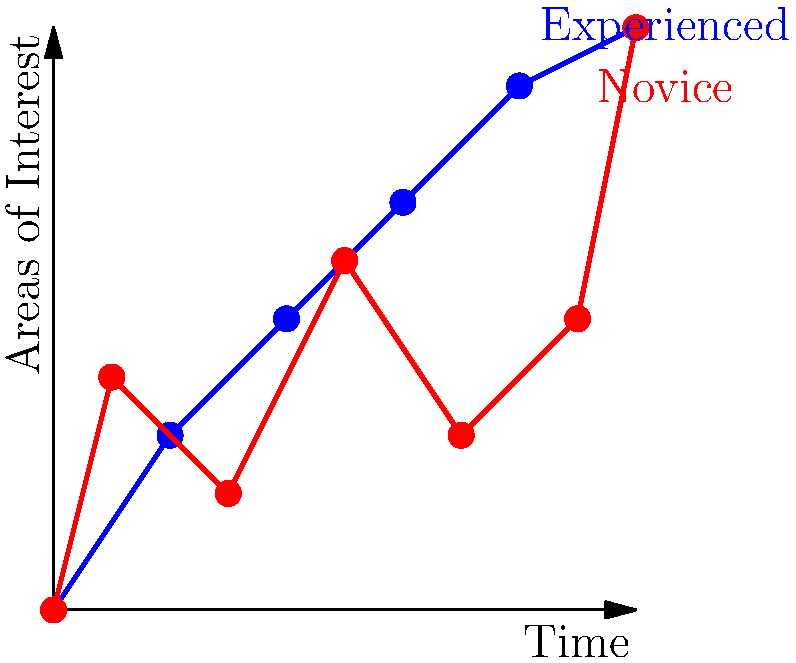Based on the gaze plot diagrams shown, which of the following statements best describes the difference in eye movement patterns between experienced and novice poker players?

A) Experienced players have more focused and direct gaze patterns
B) Novice players exhibit more consistent eye movements
C) Experienced players scan fewer areas of interest
D) Novice players have smoother transitions between areas of interest To answer this question, we need to analyze the gaze plot diagrams for both experienced and novice poker players:

1. Experienced players (blue line):
   - The line is relatively smooth and shows a more direct path from the starting point to the endpoint.
   - There are fewer fluctuations in the line, indicating more focused attention on specific areas of interest.
   - The pattern suggests efficient scanning of relevant information.

2. Novice players (red line):
   - The line shows more fluctuations and abrupt changes in direction.
   - There are more data points, indicating more frequent shifts in attention.
   - The pattern suggests less efficient scanning, with attention jumping between different areas of interest.

3. Comparing the two patterns:
   - Experienced players seem to have a more systematic and focused approach to visual information processing.
   - Novice players appear to have a more erratic and less organized visual search strategy.

4. Analyzing the options:
   A) This statement accurately describes the observed difference. Experienced players show a more direct and focused gaze pattern.
   B) This is incorrect, as novice players actually show less consistent eye movements.
   C) This is not supported by the diagram, as we can't determine the number of areas scanned.
   D) This is incorrect, as novice players show more abrupt transitions between areas of interest.

Therefore, the correct answer is option A, as it best describes the observed difference in eye movement patterns between experienced and novice poker players.
Answer: A) Experienced players have more focused and direct gaze patterns 